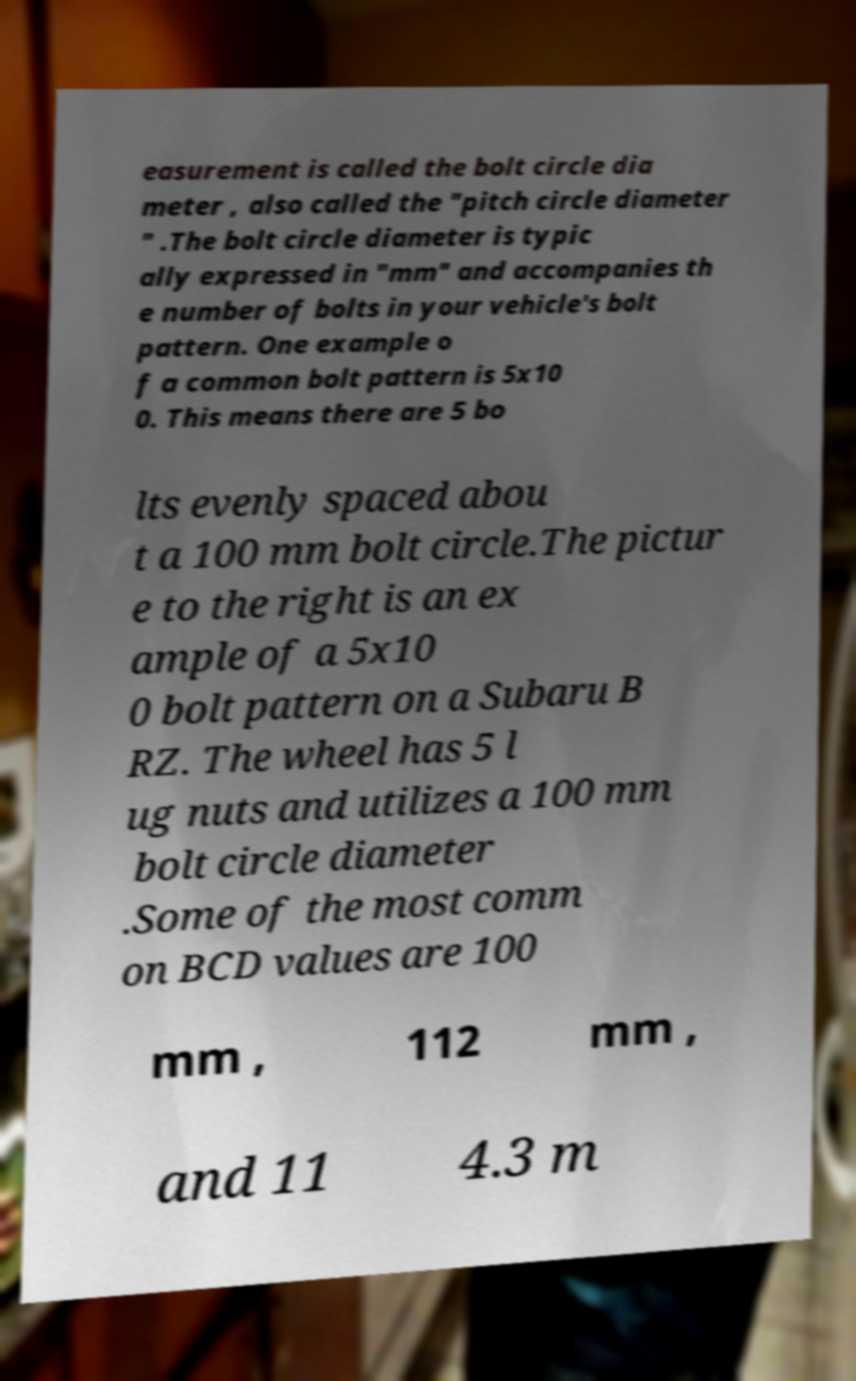What messages or text are displayed in this image? I need them in a readable, typed format. easurement is called the bolt circle dia meter , also called the "pitch circle diameter " .The bolt circle diameter is typic ally expressed in "mm" and accompanies th e number of bolts in your vehicle's bolt pattern. One example o f a common bolt pattern is 5x10 0. This means there are 5 bo lts evenly spaced abou t a 100 mm bolt circle.The pictur e to the right is an ex ample of a 5x10 0 bolt pattern on a Subaru B RZ. The wheel has 5 l ug nuts and utilizes a 100 mm bolt circle diameter .Some of the most comm on BCD values are 100 mm , 112 mm , and 11 4.3 m 